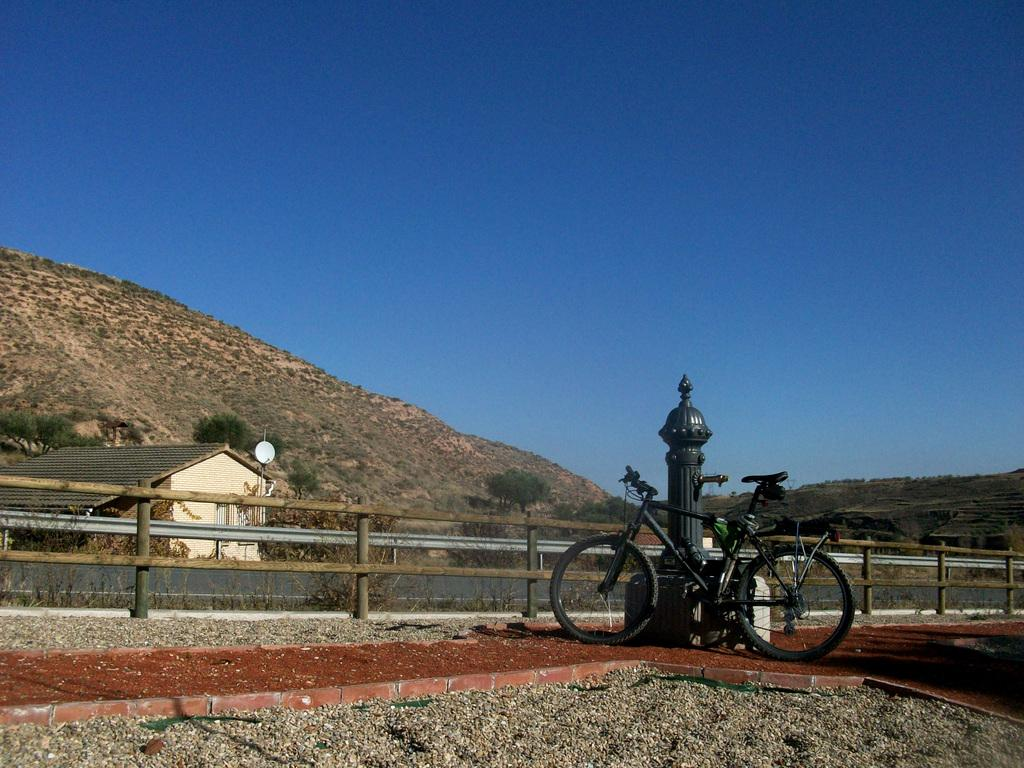What is on the ground in the image? There is a bicycle on the ground. What is the bicycle leaning on? The bicycle is leaning on an object. What can be seen in the background of the image? There is a fence, trees, a house, an antenna, a mountain, and the sky visible in the background of the image. Where is the marble located in the image? There is no marble present in the image. Can you fold the mountain in the image? The mountain in the image is a fixed, natural feature and cannot be folded. 